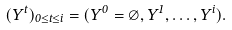<formula> <loc_0><loc_0><loc_500><loc_500>( Y ^ { t } ) _ { 0 \leq t \leq i } = ( Y ^ { 0 } = \varnothing , Y ^ { 1 } , \dots , Y ^ { i } ) .</formula> 